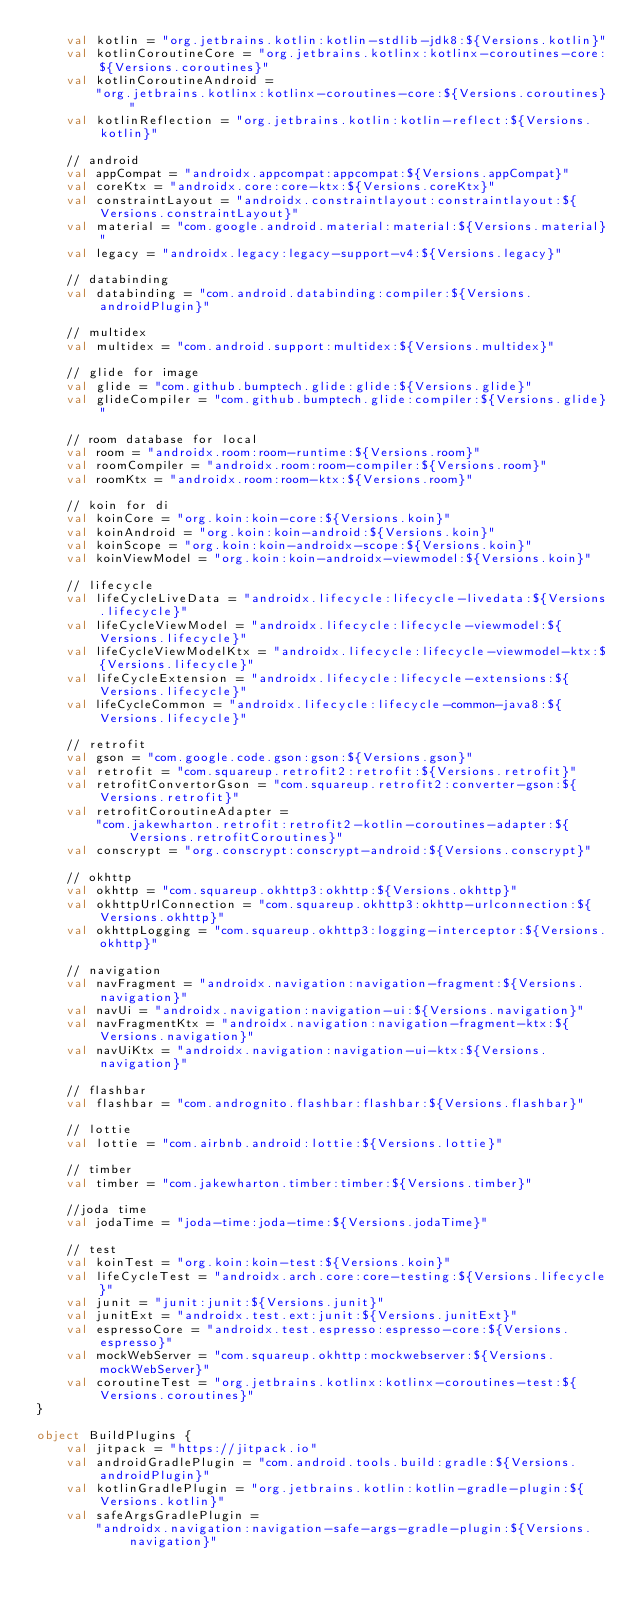<code> <loc_0><loc_0><loc_500><loc_500><_Kotlin_>    val kotlin = "org.jetbrains.kotlin:kotlin-stdlib-jdk8:${Versions.kotlin}"
    val kotlinCoroutineCore = "org.jetbrains.kotlinx:kotlinx-coroutines-core:${Versions.coroutines}"
    val kotlinCoroutineAndroid =
        "org.jetbrains.kotlinx:kotlinx-coroutines-core:${Versions.coroutines}"
    val kotlinReflection = "org.jetbrains.kotlin:kotlin-reflect:${Versions.kotlin}"

    // android
    val appCompat = "androidx.appcompat:appcompat:${Versions.appCompat}"
    val coreKtx = "androidx.core:core-ktx:${Versions.coreKtx}"
    val constraintLayout = "androidx.constraintlayout:constraintlayout:${Versions.constraintLayout}"
    val material = "com.google.android.material:material:${Versions.material}"
    val legacy = "androidx.legacy:legacy-support-v4:${Versions.legacy}"

    // databinding
    val databinding = "com.android.databinding:compiler:${Versions.androidPlugin}"

    // multidex
    val multidex = "com.android.support:multidex:${Versions.multidex}"

    // glide for image
    val glide = "com.github.bumptech.glide:glide:${Versions.glide}"
    val glideCompiler = "com.github.bumptech.glide:compiler:${Versions.glide}"

    // room database for local
    val room = "androidx.room:room-runtime:${Versions.room}"
    val roomCompiler = "androidx.room:room-compiler:${Versions.room}"
    val roomKtx = "androidx.room:room-ktx:${Versions.room}"

    // koin for di
    val koinCore = "org.koin:koin-core:${Versions.koin}"
    val koinAndroid = "org.koin:koin-android:${Versions.koin}"
    val koinScope = "org.koin:koin-androidx-scope:${Versions.koin}"
    val koinViewModel = "org.koin:koin-androidx-viewmodel:${Versions.koin}"

    // lifecycle
    val lifeCycleLiveData = "androidx.lifecycle:lifecycle-livedata:${Versions.lifecycle}"
    val lifeCycleViewModel = "androidx.lifecycle:lifecycle-viewmodel:${Versions.lifecycle}"
    val lifeCycleViewModelKtx = "androidx.lifecycle:lifecycle-viewmodel-ktx:${Versions.lifecycle}"
    val lifeCycleExtension = "androidx.lifecycle:lifecycle-extensions:${Versions.lifecycle}"
    val lifeCycleCommon = "androidx.lifecycle:lifecycle-common-java8:${Versions.lifecycle}"

    // retrofit
    val gson = "com.google.code.gson:gson:${Versions.gson}"
    val retrofit = "com.squareup.retrofit2:retrofit:${Versions.retrofit}"
    val retrofitConvertorGson = "com.squareup.retrofit2:converter-gson:${Versions.retrofit}"
    val retrofitCoroutineAdapter =
        "com.jakewharton.retrofit:retrofit2-kotlin-coroutines-adapter:${Versions.retrofitCoroutines}"
    val conscrypt = "org.conscrypt:conscrypt-android:${Versions.conscrypt}"

    // okhttp
    val okhttp = "com.squareup.okhttp3:okhttp:${Versions.okhttp}"
    val okhttpUrlConnection = "com.squareup.okhttp3:okhttp-urlconnection:${Versions.okhttp}"
    val okhttpLogging = "com.squareup.okhttp3:logging-interceptor:${Versions.okhttp}"

    // navigation
    val navFragment = "androidx.navigation:navigation-fragment:${Versions.navigation}"
    val navUi = "androidx.navigation:navigation-ui:${Versions.navigation}"
    val navFragmentKtx = "androidx.navigation:navigation-fragment-ktx:${Versions.navigation}"
    val navUiKtx = "androidx.navigation:navigation-ui-ktx:${Versions.navigation}"

    // flashbar
    val flashbar = "com.andrognito.flashbar:flashbar:${Versions.flashbar}"

    // lottie
    val lottie = "com.airbnb.android:lottie:${Versions.lottie}"

    // timber
    val timber = "com.jakewharton.timber:timber:${Versions.timber}"

    //joda time
    val jodaTime = "joda-time:joda-time:${Versions.jodaTime}"

    // test
    val koinTest = "org.koin:koin-test:${Versions.koin}"
    val lifeCycleTest = "androidx.arch.core:core-testing:${Versions.lifecycle}"
    val junit = "junit:junit:${Versions.junit}"
    val junitExt = "androidx.test.ext:junit:${Versions.junitExt}"
    val espressoCore = "androidx.test.espresso:espresso-core:${Versions.espresso}"
    val mockWebServer = "com.squareup.okhttp:mockwebserver:${Versions.mockWebServer}"
    val coroutineTest = "org.jetbrains.kotlinx:kotlinx-coroutines-test:${Versions.coroutines}"
}

object BuildPlugins {
    val jitpack = "https://jitpack.io"
    val androidGradlePlugin = "com.android.tools.build:gradle:${Versions.androidPlugin}"
    val kotlinGradlePlugin = "org.jetbrains.kotlin:kotlin-gradle-plugin:${Versions.kotlin}"
    val safeArgsGradlePlugin =
        "androidx.navigation:navigation-safe-args-gradle-plugin:${Versions.navigation}"
</code> 